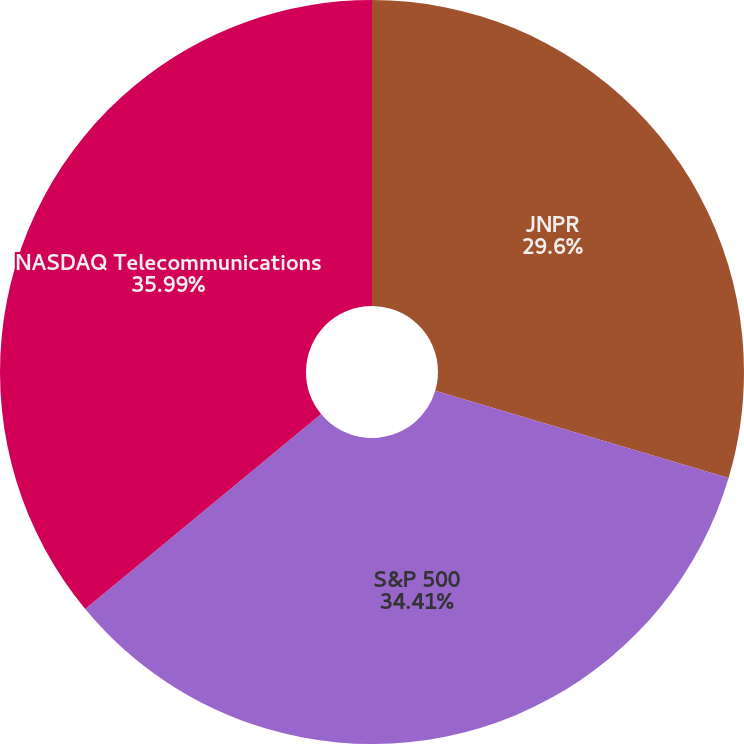<chart> <loc_0><loc_0><loc_500><loc_500><pie_chart><fcel>JNPR<fcel>S&P 500<fcel>NASDAQ Telecommunications<nl><fcel>29.6%<fcel>34.41%<fcel>35.99%<nl></chart> 